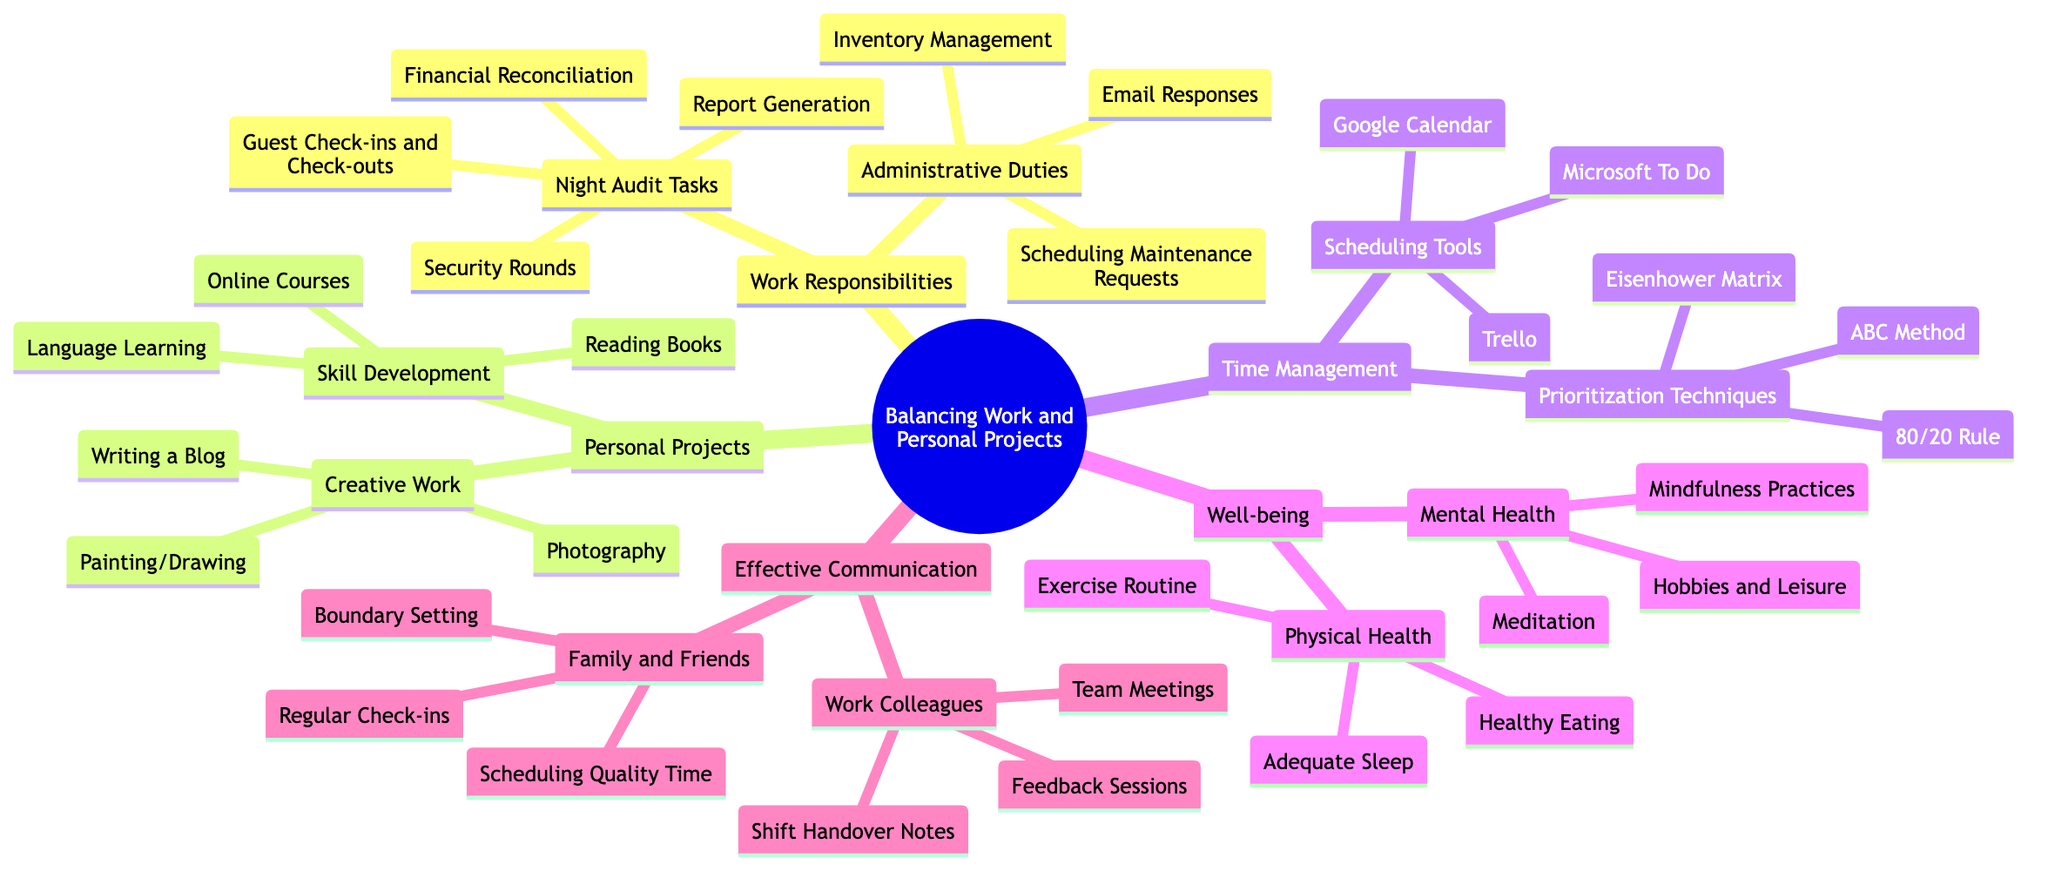What are the main categories of the mind map? The diagram includes five main categories: Work Responsibilities, Personal Projects, Time Management, Well-being, and Effective Communication.
Answer: Work Responsibilities, Personal Projects, Time Management, Well-being, Effective Communication How many subtopics are under Personal Projects? Under Personal Projects, there are two subtopics: Creative Work and Skill Development. Hence, the count of subtopics is two.
Answer: 2 What tasks are included in Night Audit Tasks? The Night Audit Tasks include four specific tasks: Guest Check-ins and Check-outs, Financial Reconciliation, Report Generation, and Security Rounds. Therefore, the answer encompasses all four tasks mentioned.
Answer: Guest Check-ins and Check-outs, Financial Reconciliation, Report Generation, Security Rounds Which time management technique is mentioned first? The first time management technique listed under Prioritization Techniques is the Eisenhower Matrix. This is determined by the order presented in the mind map.
Answer: Eisenhower Matrix How many types of well-being are listed? The well-being category includes two types: Physical Health and Mental Health. This is counted directly from the subtopics in that category.
Answer: 2 What is the relationship between Administrative Duties and Email Responses? Administrative Duties is a subtopic of Work Responsibilities, and Email Responses is a subtopic of Administrative Duties. This shows a hierarchical relationship where Administrative Duties leads to Email Responses.
Answer: Hierarchical relationship Which scheduling tool is listed last? In the Scheduling Tools section, Microsoft To Do is the last item mentioned. This conclusion is derived by reading the items in the list sequentially.
Answer: Microsoft To Do How many total tasks are listed under Creative Work? The Creative Work consists of three tasks: Writing a Blog, Painting/Drawing, and Photography. Therefore, the total count here is three.
Answer: 3 What is the main focus of the Effective Communication section? The Effective Communication section is divided into two main aspects: Work Colleagues and Family and Friends. Thus, the focus centers on communication across different relationships.
Answer: Work Colleagues, Family and Friends 